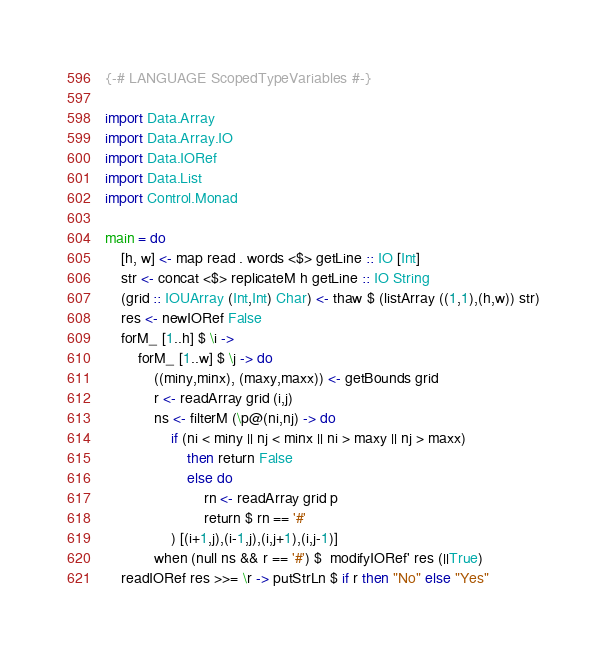Convert code to text. <code><loc_0><loc_0><loc_500><loc_500><_Haskell_>{-# LANGUAGE ScopedTypeVariables #-}

import Data.Array
import Data.Array.IO
import Data.IORef
import Data.List
import Control.Monad

main = do
    [h, w] <- map read . words <$> getLine :: IO [Int]
    str <- concat <$> replicateM h getLine :: IO String
    (grid :: IOUArray (Int,Int) Char) <- thaw $ (listArray ((1,1),(h,w)) str)
    res <- newIORef False
    forM_ [1..h] $ \i ->
        forM_ [1..w] $ \j -> do
            ((miny,minx), (maxy,maxx)) <- getBounds grid
            r <- readArray grid (i,j)
            ns <- filterM (\p@(ni,nj) -> do
                if (ni < miny || nj < minx || ni > maxy || nj > maxx)
                    then return False
                    else do
                        rn <- readArray grid p
                        return $ rn == '#' 
                ) [(i+1,j),(i-1,j),(i,j+1),(i,j-1)]
            when (null ns && r == '#') $  modifyIORef' res (||True)
    readIORef res >>= \r -> putStrLn $ if r then "No" else "Yes"</code> 